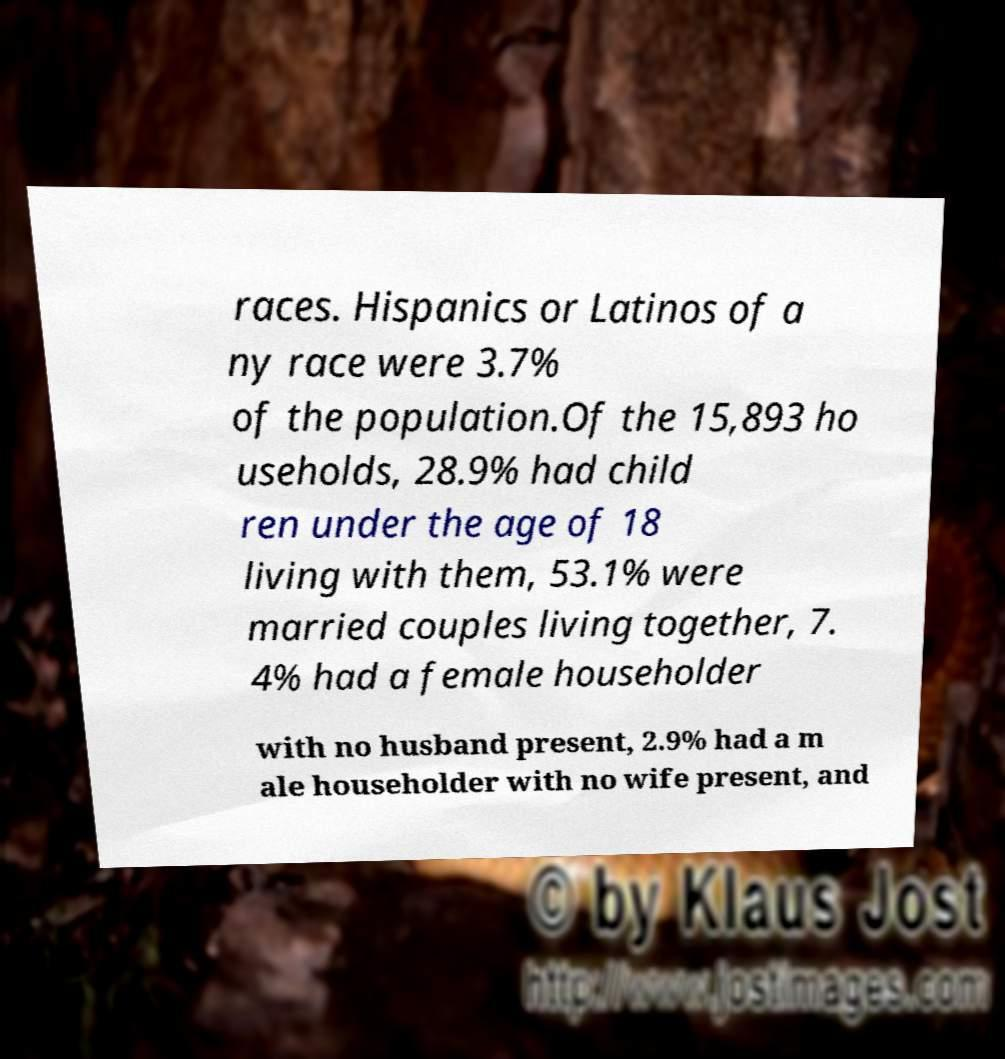What messages or text are displayed in this image? I need them in a readable, typed format. races. Hispanics or Latinos of a ny race were 3.7% of the population.Of the 15,893 ho useholds, 28.9% had child ren under the age of 18 living with them, 53.1% were married couples living together, 7. 4% had a female householder with no husband present, 2.9% had a m ale householder with no wife present, and 